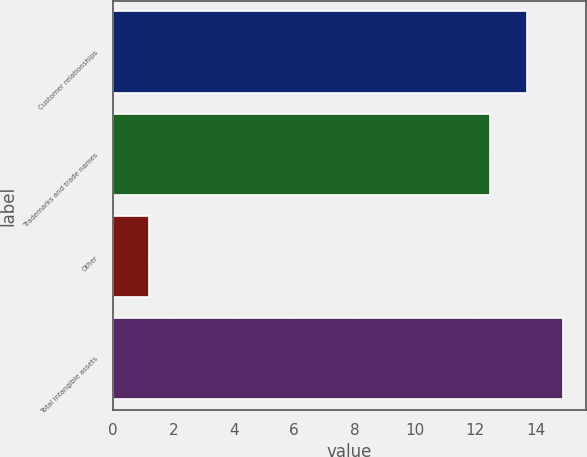<chart> <loc_0><loc_0><loc_500><loc_500><bar_chart><fcel>Customer relationships<fcel>Trademarks and trade names<fcel>Other<fcel>Total intangible assets<nl><fcel>13.71<fcel>12.5<fcel>1.2<fcel>14.92<nl></chart> 